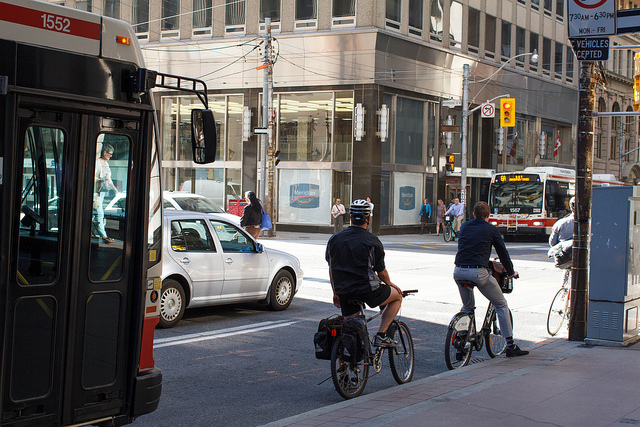Read and extract the text from this image. 1552 BA CEPTEO YEHTOLES FRI MON 630 PY AM 730 